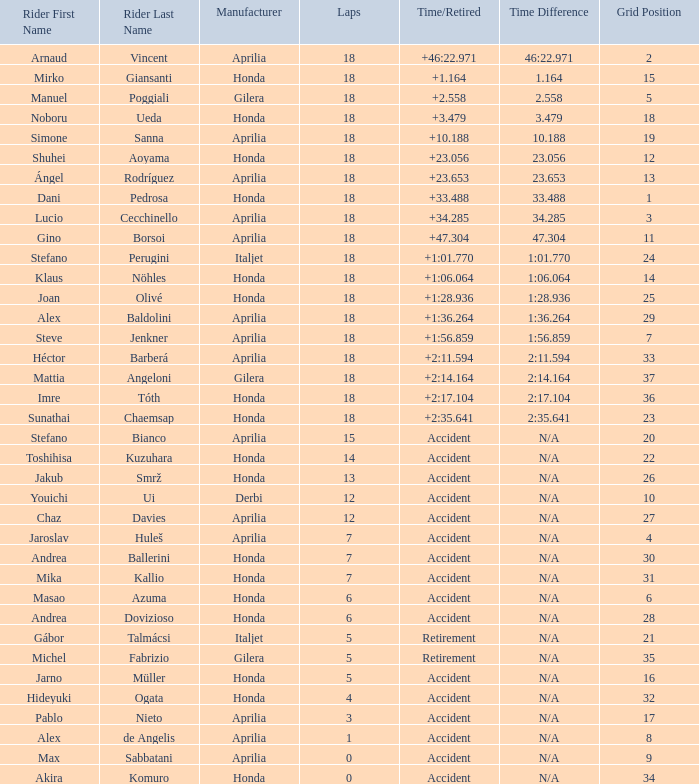Which competitor has less than 15 laps to their name, more than 32 grid entries, and an incident causing them to retire? Akira Komuro. 